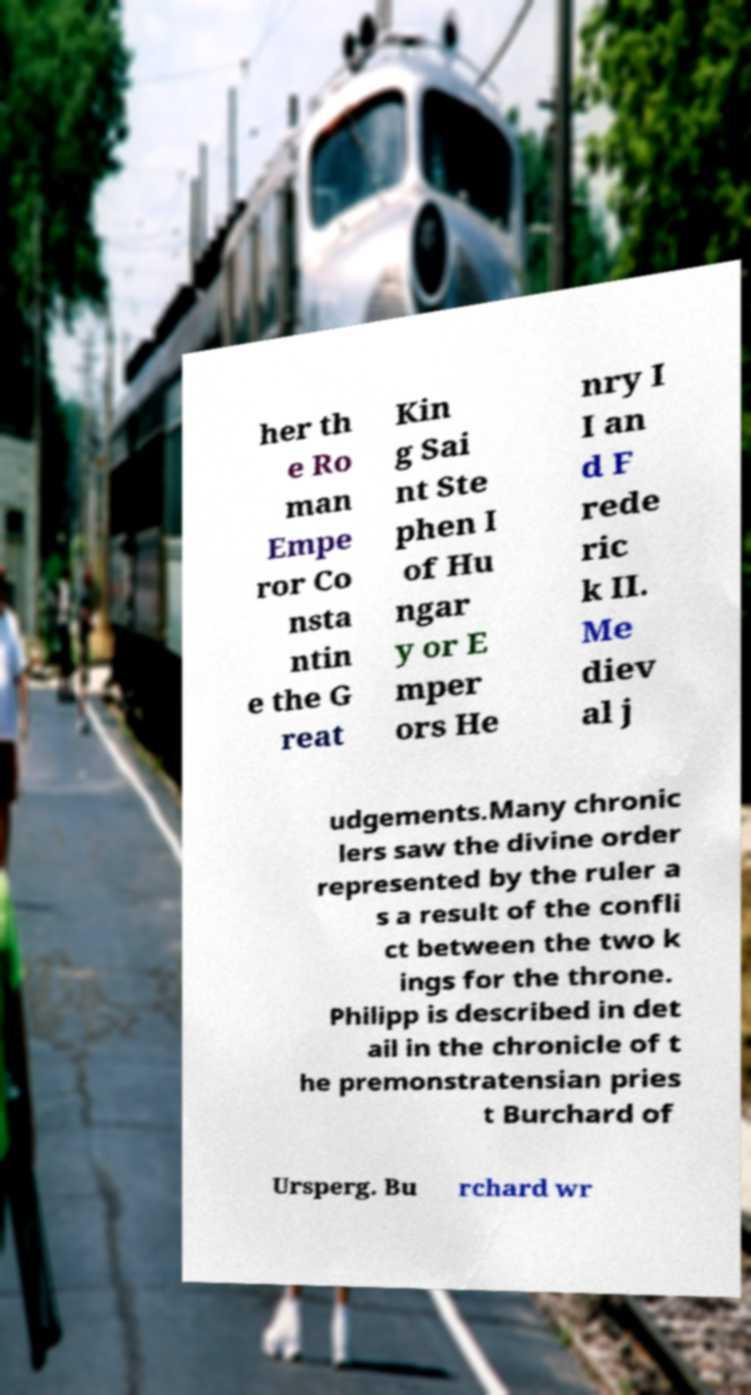Could you extract and type out the text from this image? her th e Ro man Empe ror Co nsta ntin e the G reat Kin g Sai nt Ste phen I of Hu ngar y or E mper ors He nry I I an d F rede ric k II. Me diev al j udgements.Many chronic lers saw the divine order represented by the ruler a s a result of the confli ct between the two k ings for the throne. Philipp is described in det ail in the chronicle of t he premonstratensian pries t Burchard of Ursperg. Bu rchard wr 